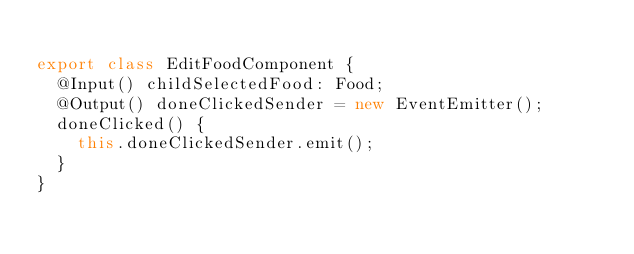<code> <loc_0><loc_0><loc_500><loc_500><_TypeScript_>
export class EditFoodComponent {
  @Input() childSelectedFood: Food;
  @Output() doneClickedSender = new EventEmitter();
  doneClicked() {
    this.doneClickedSender.emit();
  }
}
</code> 